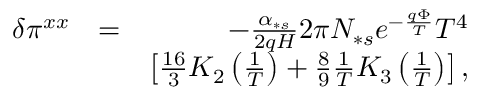Convert formula to latex. <formula><loc_0><loc_0><loc_500><loc_500>\begin{array} { r l r } { \delta \pi ^ { x x } } & { = } & { - \frac { \alpha _ { \ast s } } { 2 q H } 2 \pi N _ { \ast s } e ^ { - \frac { q \Phi } { T } } T ^ { 4 } } \\ & { \left [ \frac { 1 6 } { 3 } K _ { 2 } \left ( \frac { 1 } { T } \right ) + \frac { 8 } { 9 } \frac { 1 } { T } K _ { 3 } \left ( \frac { 1 } { T } \right ) \right ] , } \end{array}</formula> 